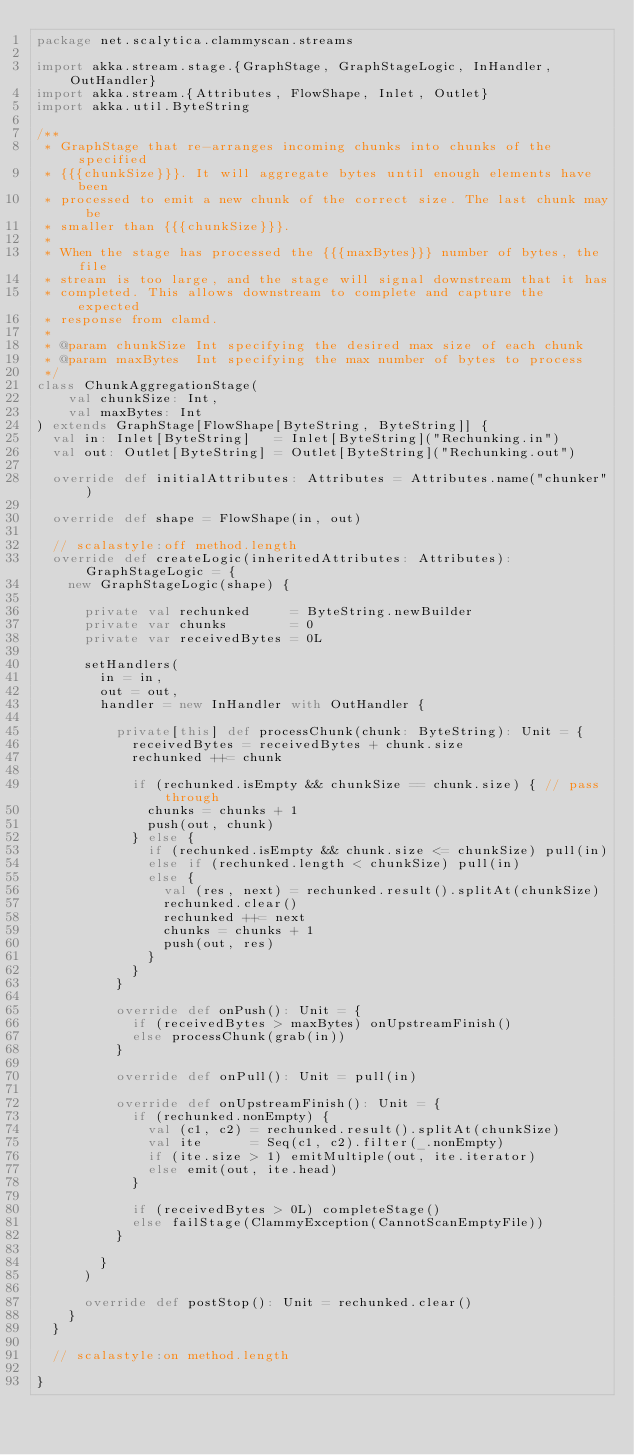Convert code to text. <code><loc_0><loc_0><loc_500><loc_500><_Scala_>package net.scalytica.clammyscan.streams

import akka.stream.stage.{GraphStage, GraphStageLogic, InHandler, OutHandler}
import akka.stream.{Attributes, FlowShape, Inlet, Outlet}
import akka.util.ByteString

/**
 * GraphStage that re-arranges incoming chunks into chunks of the specified
 * {{{chunkSize}}}. It will aggregate bytes until enough elements have been
 * processed to emit a new chunk of the correct size. The last chunk may be
 * smaller than {{{chunkSize}}}.
 *
 * When the stage has processed the {{{maxBytes}}} number of bytes, the file
 * stream is too large, and the stage will signal downstream that it has
 * completed. This allows downstream to complete and capture the expected
 * response from clamd.
 *
 * @param chunkSize Int specifying the desired max size of each chunk
 * @param maxBytes  Int specifying the max number of bytes to process
 */
class ChunkAggregationStage(
    val chunkSize: Int,
    val maxBytes: Int
) extends GraphStage[FlowShape[ByteString, ByteString]] {
  val in: Inlet[ByteString]   = Inlet[ByteString]("Rechunking.in")
  val out: Outlet[ByteString] = Outlet[ByteString]("Rechunking.out")

  override def initialAttributes: Attributes = Attributes.name("chunker")

  override def shape = FlowShape(in, out)

  // scalastyle:off method.length
  override def createLogic(inheritedAttributes: Attributes): GraphStageLogic = {
    new GraphStageLogic(shape) {

      private val rechunked     = ByteString.newBuilder
      private var chunks        = 0
      private var receivedBytes = 0L

      setHandlers(
        in = in,
        out = out,
        handler = new InHandler with OutHandler {

          private[this] def processChunk(chunk: ByteString): Unit = {
            receivedBytes = receivedBytes + chunk.size
            rechunked ++= chunk

            if (rechunked.isEmpty && chunkSize == chunk.size) { // pass through
              chunks = chunks + 1
              push(out, chunk)
            } else {
              if (rechunked.isEmpty && chunk.size <= chunkSize) pull(in)
              else if (rechunked.length < chunkSize) pull(in)
              else {
                val (res, next) = rechunked.result().splitAt(chunkSize)
                rechunked.clear()
                rechunked ++= next
                chunks = chunks + 1
                push(out, res)
              }
            }
          }

          override def onPush(): Unit = {
            if (receivedBytes > maxBytes) onUpstreamFinish()
            else processChunk(grab(in))
          }

          override def onPull(): Unit = pull(in)

          override def onUpstreamFinish(): Unit = {
            if (rechunked.nonEmpty) {
              val (c1, c2) = rechunked.result().splitAt(chunkSize)
              val ite      = Seq(c1, c2).filter(_.nonEmpty)
              if (ite.size > 1) emitMultiple(out, ite.iterator)
              else emit(out, ite.head)
            }

            if (receivedBytes > 0L) completeStage()
            else failStage(ClammyException(CannotScanEmptyFile))
          }

        }
      )

      override def postStop(): Unit = rechunked.clear()
    }
  }

  // scalastyle:on method.length

}
</code> 